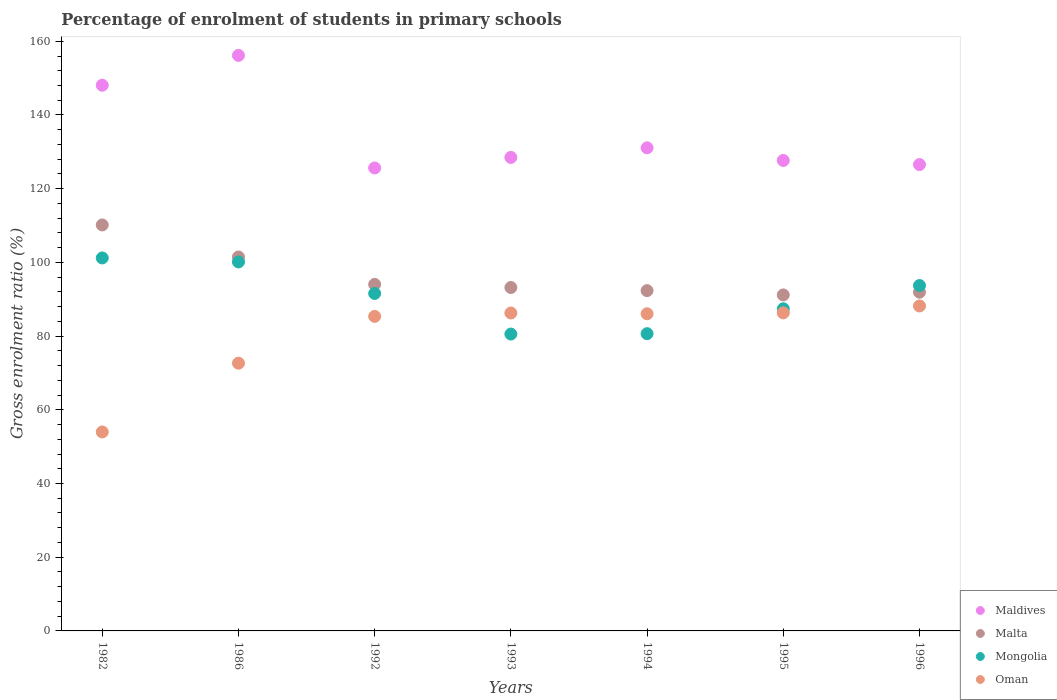How many different coloured dotlines are there?
Provide a short and direct response. 4. Is the number of dotlines equal to the number of legend labels?
Give a very brief answer. Yes. What is the percentage of students enrolled in primary schools in Maldives in 1993?
Offer a very short reply. 128.49. Across all years, what is the maximum percentage of students enrolled in primary schools in Malta?
Your answer should be very brief. 110.16. Across all years, what is the minimum percentage of students enrolled in primary schools in Mongolia?
Make the answer very short. 80.56. In which year was the percentage of students enrolled in primary schools in Maldives minimum?
Offer a very short reply. 1992. What is the total percentage of students enrolled in primary schools in Malta in the graph?
Make the answer very short. 674.29. What is the difference between the percentage of students enrolled in primary schools in Mongolia in 1982 and that in 1996?
Your response must be concise. 7.49. What is the difference between the percentage of students enrolled in primary schools in Oman in 1994 and the percentage of students enrolled in primary schools in Mongolia in 1995?
Provide a short and direct response. -1.35. What is the average percentage of students enrolled in primary schools in Mongolia per year?
Keep it short and to the point. 90.75. In the year 1982, what is the difference between the percentage of students enrolled in primary schools in Maldives and percentage of students enrolled in primary schools in Oman?
Offer a terse response. 94.08. What is the ratio of the percentage of students enrolled in primary schools in Mongolia in 1982 to that in 1994?
Provide a short and direct response. 1.25. Is the percentage of students enrolled in primary schools in Maldives in 1986 less than that in 1992?
Your answer should be compact. No. What is the difference between the highest and the second highest percentage of students enrolled in primary schools in Mongolia?
Give a very brief answer. 1.08. What is the difference between the highest and the lowest percentage of students enrolled in primary schools in Mongolia?
Offer a terse response. 20.65. In how many years, is the percentage of students enrolled in primary schools in Mongolia greater than the average percentage of students enrolled in primary schools in Mongolia taken over all years?
Your answer should be compact. 4. Is it the case that in every year, the sum of the percentage of students enrolled in primary schools in Mongolia and percentage of students enrolled in primary schools in Maldives  is greater than the sum of percentage of students enrolled in primary schools in Malta and percentage of students enrolled in primary schools in Oman?
Offer a very short reply. Yes. Is it the case that in every year, the sum of the percentage of students enrolled in primary schools in Malta and percentage of students enrolled in primary schools in Mongolia  is greater than the percentage of students enrolled in primary schools in Maldives?
Your response must be concise. Yes. Does the percentage of students enrolled in primary schools in Oman monotonically increase over the years?
Offer a very short reply. No. Is the percentage of students enrolled in primary schools in Maldives strictly greater than the percentage of students enrolled in primary schools in Oman over the years?
Keep it short and to the point. Yes. Is the percentage of students enrolled in primary schools in Oman strictly less than the percentage of students enrolled in primary schools in Malta over the years?
Make the answer very short. Yes. How many dotlines are there?
Your response must be concise. 4. How many years are there in the graph?
Your response must be concise. 7. What is the difference between two consecutive major ticks on the Y-axis?
Ensure brevity in your answer.  20. Does the graph contain any zero values?
Offer a terse response. No. Does the graph contain grids?
Provide a short and direct response. No. How many legend labels are there?
Give a very brief answer. 4. What is the title of the graph?
Your answer should be very brief. Percentage of enrolment of students in primary schools. Does "Ecuador" appear as one of the legend labels in the graph?
Keep it short and to the point. No. What is the Gross enrolment ratio (%) in Maldives in 1982?
Keep it short and to the point. 148.08. What is the Gross enrolment ratio (%) of Malta in 1982?
Provide a short and direct response. 110.16. What is the Gross enrolment ratio (%) of Mongolia in 1982?
Your response must be concise. 101.21. What is the Gross enrolment ratio (%) in Oman in 1982?
Ensure brevity in your answer.  53.99. What is the Gross enrolment ratio (%) in Maldives in 1986?
Keep it short and to the point. 156.17. What is the Gross enrolment ratio (%) of Malta in 1986?
Your response must be concise. 101.47. What is the Gross enrolment ratio (%) of Mongolia in 1986?
Give a very brief answer. 100.12. What is the Gross enrolment ratio (%) of Oman in 1986?
Your response must be concise. 72.65. What is the Gross enrolment ratio (%) in Maldives in 1992?
Keep it short and to the point. 125.62. What is the Gross enrolment ratio (%) in Malta in 1992?
Keep it short and to the point. 94.04. What is the Gross enrolment ratio (%) of Mongolia in 1992?
Ensure brevity in your answer.  91.57. What is the Gross enrolment ratio (%) of Oman in 1992?
Your answer should be compact. 85.35. What is the Gross enrolment ratio (%) of Maldives in 1993?
Offer a terse response. 128.49. What is the Gross enrolment ratio (%) in Malta in 1993?
Offer a very short reply. 93.19. What is the Gross enrolment ratio (%) in Mongolia in 1993?
Provide a succinct answer. 80.56. What is the Gross enrolment ratio (%) of Oman in 1993?
Keep it short and to the point. 86.27. What is the Gross enrolment ratio (%) of Maldives in 1994?
Provide a succinct answer. 131.1. What is the Gross enrolment ratio (%) of Malta in 1994?
Provide a succinct answer. 92.34. What is the Gross enrolment ratio (%) in Mongolia in 1994?
Your response must be concise. 80.66. What is the Gross enrolment ratio (%) of Oman in 1994?
Your answer should be compact. 86.07. What is the Gross enrolment ratio (%) of Maldives in 1995?
Provide a succinct answer. 127.66. What is the Gross enrolment ratio (%) in Malta in 1995?
Provide a short and direct response. 91.18. What is the Gross enrolment ratio (%) in Mongolia in 1995?
Your answer should be very brief. 87.42. What is the Gross enrolment ratio (%) in Oman in 1995?
Your answer should be compact. 86.31. What is the Gross enrolment ratio (%) in Maldives in 1996?
Your response must be concise. 126.55. What is the Gross enrolment ratio (%) of Malta in 1996?
Keep it short and to the point. 91.91. What is the Gross enrolment ratio (%) in Mongolia in 1996?
Your answer should be compact. 93.72. What is the Gross enrolment ratio (%) in Oman in 1996?
Keep it short and to the point. 88.18. Across all years, what is the maximum Gross enrolment ratio (%) of Maldives?
Make the answer very short. 156.17. Across all years, what is the maximum Gross enrolment ratio (%) of Malta?
Provide a succinct answer. 110.16. Across all years, what is the maximum Gross enrolment ratio (%) of Mongolia?
Give a very brief answer. 101.21. Across all years, what is the maximum Gross enrolment ratio (%) in Oman?
Your answer should be compact. 88.18. Across all years, what is the minimum Gross enrolment ratio (%) in Maldives?
Offer a terse response. 125.62. Across all years, what is the minimum Gross enrolment ratio (%) in Malta?
Ensure brevity in your answer.  91.18. Across all years, what is the minimum Gross enrolment ratio (%) in Mongolia?
Your response must be concise. 80.56. Across all years, what is the minimum Gross enrolment ratio (%) of Oman?
Your answer should be very brief. 53.99. What is the total Gross enrolment ratio (%) of Maldives in the graph?
Ensure brevity in your answer.  943.66. What is the total Gross enrolment ratio (%) in Malta in the graph?
Give a very brief answer. 674.29. What is the total Gross enrolment ratio (%) in Mongolia in the graph?
Make the answer very short. 635.26. What is the total Gross enrolment ratio (%) of Oman in the graph?
Your answer should be very brief. 558.82. What is the difference between the Gross enrolment ratio (%) in Maldives in 1982 and that in 1986?
Your response must be concise. -8.09. What is the difference between the Gross enrolment ratio (%) of Malta in 1982 and that in 1986?
Give a very brief answer. 8.7. What is the difference between the Gross enrolment ratio (%) of Mongolia in 1982 and that in 1986?
Provide a succinct answer. 1.08. What is the difference between the Gross enrolment ratio (%) of Oman in 1982 and that in 1986?
Offer a terse response. -18.66. What is the difference between the Gross enrolment ratio (%) in Maldives in 1982 and that in 1992?
Make the answer very short. 22.45. What is the difference between the Gross enrolment ratio (%) of Malta in 1982 and that in 1992?
Make the answer very short. 16.13. What is the difference between the Gross enrolment ratio (%) in Mongolia in 1982 and that in 1992?
Ensure brevity in your answer.  9.64. What is the difference between the Gross enrolment ratio (%) of Oman in 1982 and that in 1992?
Provide a short and direct response. -31.36. What is the difference between the Gross enrolment ratio (%) in Maldives in 1982 and that in 1993?
Provide a short and direct response. 19.59. What is the difference between the Gross enrolment ratio (%) in Malta in 1982 and that in 1993?
Make the answer very short. 16.98. What is the difference between the Gross enrolment ratio (%) in Mongolia in 1982 and that in 1993?
Make the answer very short. 20.65. What is the difference between the Gross enrolment ratio (%) of Oman in 1982 and that in 1993?
Ensure brevity in your answer.  -32.28. What is the difference between the Gross enrolment ratio (%) in Maldives in 1982 and that in 1994?
Provide a succinct answer. 16.98. What is the difference between the Gross enrolment ratio (%) in Malta in 1982 and that in 1994?
Ensure brevity in your answer.  17.82. What is the difference between the Gross enrolment ratio (%) of Mongolia in 1982 and that in 1994?
Your answer should be very brief. 20.55. What is the difference between the Gross enrolment ratio (%) in Oman in 1982 and that in 1994?
Your answer should be very brief. -32.08. What is the difference between the Gross enrolment ratio (%) of Maldives in 1982 and that in 1995?
Provide a succinct answer. 20.41. What is the difference between the Gross enrolment ratio (%) of Malta in 1982 and that in 1995?
Your answer should be very brief. 18.99. What is the difference between the Gross enrolment ratio (%) in Mongolia in 1982 and that in 1995?
Your answer should be compact. 13.79. What is the difference between the Gross enrolment ratio (%) in Oman in 1982 and that in 1995?
Make the answer very short. -32.32. What is the difference between the Gross enrolment ratio (%) of Maldives in 1982 and that in 1996?
Provide a short and direct response. 21.53. What is the difference between the Gross enrolment ratio (%) of Malta in 1982 and that in 1996?
Ensure brevity in your answer.  18.25. What is the difference between the Gross enrolment ratio (%) of Mongolia in 1982 and that in 1996?
Your response must be concise. 7.49. What is the difference between the Gross enrolment ratio (%) of Oman in 1982 and that in 1996?
Your answer should be compact. -34.19. What is the difference between the Gross enrolment ratio (%) in Maldives in 1986 and that in 1992?
Your answer should be compact. 30.55. What is the difference between the Gross enrolment ratio (%) in Malta in 1986 and that in 1992?
Your answer should be very brief. 7.43. What is the difference between the Gross enrolment ratio (%) in Mongolia in 1986 and that in 1992?
Your answer should be very brief. 8.55. What is the difference between the Gross enrolment ratio (%) of Oman in 1986 and that in 1992?
Keep it short and to the point. -12.7. What is the difference between the Gross enrolment ratio (%) in Maldives in 1986 and that in 1993?
Your answer should be very brief. 27.68. What is the difference between the Gross enrolment ratio (%) in Malta in 1986 and that in 1993?
Keep it short and to the point. 8.28. What is the difference between the Gross enrolment ratio (%) in Mongolia in 1986 and that in 1993?
Provide a succinct answer. 19.57. What is the difference between the Gross enrolment ratio (%) in Oman in 1986 and that in 1993?
Your answer should be compact. -13.62. What is the difference between the Gross enrolment ratio (%) in Maldives in 1986 and that in 1994?
Give a very brief answer. 25.07. What is the difference between the Gross enrolment ratio (%) in Malta in 1986 and that in 1994?
Provide a short and direct response. 9.13. What is the difference between the Gross enrolment ratio (%) of Mongolia in 1986 and that in 1994?
Keep it short and to the point. 19.46. What is the difference between the Gross enrolment ratio (%) of Oman in 1986 and that in 1994?
Ensure brevity in your answer.  -13.42. What is the difference between the Gross enrolment ratio (%) in Maldives in 1986 and that in 1995?
Your response must be concise. 28.51. What is the difference between the Gross enrolment ratio (%) in Malta in 1986 and that in 1995?
Offer a very short reply. 10.29. What is the difference between the Gross enrolment ratio (%) of Mongolia in 1986 and that in 1995?
Your response must be concise. 12.71. What is the difference between the Gross enrolment ratio (%) of Oman in 1986 and that in 1995?
Provide a succinct answer. -13.66. What is the difference between the Gross enrolment ratio (%) in Maldives in 1986 and that in 1996?
Offer a terse response. 29.62. What is the difference between the Gross enrolment ratio (%) in Malta in 1986 and that in 1996?
Offer a very short reply. 9.55. What is the difference between the Gross enrolment ratio (%) in Mongolia in 1986 and that in 1996?
Give a very brief answer. 6.4. What is the difference between the Gross enrolment ratio (%) of Oman in 1986 and that in 1996?
Provide a short and direct response. -15.53. What is the difference between the Gross enrolment ratio (%) in Maldives in 1992 and that in 1993?
Your response must be concise. -2.86. What is the difference between the Gross enrolment ratio (%) of Malta in 1992 and that in 1993?
Offer a very short reply. 0.85. What is the difference between the Gross enrolment ratio (%) of Mongolia in 1992 and that in 1993?
Offer a terse response. 11.02. What is the difference between the Gross enrolment ratio (%) of Oman in 1992 and that in 1993?
Make the answer very short. -0.92. What is the difference between the Gross enrolment ratio (%) of Maldives in 1992 and that in 1994?
Ensure brevity in your answer.  -5.47. What is the difference between the Gross enrolment ratio (%) in Malta in 1992 and that in 1994?
Offer a terse response. 1.7. What is the difference between the Gross enrolment ratio (%) of Mongolia in 1992 and that in 1994?
Offer a very short reply. 10.91. What is the difference between the Gross enrolment ratio (%) of Oman in 1992 and that in 1994?
Keep it short and to the point. -0.72. What is the difference between the Gross enrolment ratio (%) in Maldives in 1992 and that in 1995?
Your response must be concise. -2.04. What is the difference between the Gross enrolment ratio (%) in Malta in 1992 and that in 1995?
Ensure brevity in your answer.  2.86. What is the difference between the Gross enrolment ratio (%) in Mongolia in 1992 and that in 1995?
Your answer should be compact. 4.16. What is the difference between the Gross enrolment ratio (%) of Oman in 1992 and that in 1995?
Your answer should be very brief. -0.97. What is the difference between the Gross enrolment ratio (%) in Maldives in 1992 and that in 1996?
Give a very brief answer. -0.93. What is the difference between the Gross enrolment ratio (%) of Malta in 1992 and that in 1996?
Provide a short and direct response. 2.12. What is the difference between the Gross enrolment ratio (%) of Mongolia in 1992 and that in 1996?
Provide a short and direct response. -2.15. What is the difference between the Gross enrolment ratio (%) in Oman in 1992 and that in 1996?
Provide a short and direct response. -2.83. What is the difference between the Gross enrolment ratio (%) in Maldives in 1993 and that in 1994?
Your answer should be compact. -2.61. What is the difference between the Gross enrolment ratio (%) in Malta in 1993 and that in 1994?
Ensure brevity in your answer.  0.84. What is the difference between the Gross enrolment ratio (%) in Mongolia in 1993 and that in 1994?
Ensure brevity in your answer.  -0.1. What is the difference between the Gross enrolment ratio (%) in Oman in 1993 and that in 1994?
Provide a succinct answer. 0.2. What is the difference between the Gross enrolment ratio (%) of Maldives in 1993 and that in 1995?
Offer a terse response. 0.82. What is the difference between the Gross enrolment ratio (%) in Malta in 1993 and that in 1995?
Ensure brevity in your answer.  2.01. What is the difference between the Gross enrolment ratio (%) of Mongolia in 1993 and that in 1995?
Give a very brief answer. -6.86. What is the difference between the Gross enrolment ratio (%) in Oman in 1993 and that in 1995?
Your answer should be very brief. -0.04. What is the difference between the Gross enrolment ratio (%) in Maldives in 1993 and that in 1996?
Your answer should be compact. 1.94. What is the difference between the Gross enrolment ratio (%) in Malta in 1993 and that in 1996?
Ensure brevity in your answer.  1.27. What is the difference between the Gross enrolment ratio (%) in Mongolia in 1993 and that in 1996?
Offer a terse response. -13.16. What is the difference between the Gross enrolment ratio (%) in Oman in 1993 and that in 1996?
Provide a short and direct response. -1.91. What is the difference between the Gross enrolment ratio (%) in Maldives in 1994 and that in 1995?
Keep it short and to the point. 3.43. What is the difference between the Gross enrolment ratio (%) in Malta in 1994 and that in 1995?
Keep it short and to the point. 1.17. What is the difference between the Gross enrolment ratio (%) of Mongolia in 1994 and that in 1995?
Make the answer very short. -6.76. What is the difference between the Gross enrolment ratio (%) in Oman in 1994 and that in 1995?
Make the answer very short. -0.24. What is the difference between the Gross enrolment ratio (%) in Maldives in 1994 and that in 1996?
Ensure brevity in your answer.  4.55. What is the difference between the Gross enrolment ratio (%) in Malta in 1994 and that in 1996?
Ensure brevity in your answer.  0.43. What is the difference between the Gross enrolment ratio (%) in Mongolia in 1994 and that in 1996?
Make the answer very short. -13.06. What is the difference between the Gross enrolment ratio (%) of Oman in 1994 and that in 1996?
Provide a short and direct response. -2.11. What is the difference between the Gross enrolment ratio (%) of Maldives in 1995 and that in 1996?
Your response must be concise. 1.11. What is the difference between the Gross enrolment ratio (%) in Malta in 1995 and that in 1996?
Ensure brevity in your answer.  -0.74. What is the difference between the Gross enrolment ratio (%) in Mongolia in 1995 and that in 1996?
Your response must be concise. -6.31. What is the difference between the Gross enrolment ratio (%) in Oman in 1995 and that in 1996?
Give a very brief answer. -1.87. What is the difference between the Gross enrolment ratio (%) of Maldives in 1982 and the Gross enrolment ratio (%) of Malta in 1986?
Your answer should be compact. 46.61. What is the difference between the Gross enrolment ratio (%) in Maldives in 1982 and the Gross enrolment ratio (%) in Mongolia in 1986?
Make the answer very short. 47.95. What is the difference between the Gross enrolment ratio (%) in Maldives in 1982 and the Gross enrolment ratio (%) in Oman in 1986?
Your response must be concise. 75.43. What is the difference between the Gross enrolment ratio (%) of Malta in 1982 and the Gross enrolment ratio (%) of Mongolia in 1986?
Your answer should be very brief. 10.04. What is the difference between the Gross enrolment ratio (%) of Malta in 1982 and the Gross enrolment ratio (%) of Oman in 1986?
Your answer should be compact. 37.52. What is the difference between the Gross enrolment ratio (%) in Mongolia in 1982 and the Gross enrolment ratio (%) in Oman in 1986?
Keep it short and to the point. 28.56. What is the difference between the Gross enrolment ratio (%) in Maldives in 1982 and the Gross enrolment ratio (%) in Malta in 1992?
Make the answer very short. 54.04. What is the difference between the Gross enrolment ratio (%) of Maldives in 1982 and the Gross enrolment ratio (%) of Mongolia in 1992?
Offer a terse response. 56.5. What is the difference between the Gross enrolment ratio (%) of Maldives in 1982 and the Gross enrolment ratio (%) of Oman in 1992?
Keep it short and to the point. 62.73. What is the difference between the Gross enrolment ratio (%) of Malta in 1982 and the Gross enrolment ratio (%) of Mongolia in 1992?
Give a very brief answer. 18.59. What is the difference between the Gross enrolment ratio (%) of Malta in 1982 and the Gross enrolment ratio (%) of Oman in 1992?
Give a very brief answer. 24.82. What is the difference between the Gross enrolment ratio (%) of Mongolia in 1982 and the Gross enrolment ratio (%) of Oman in 1992?
Provide a succinct answer. 15.86. What is the difference between the Gross enrolment ratio (%) in Maldives in 1982 and the Gross enrolment ratio (%) in Malta in 1993?
Ensure brevity in your answer.  54.89. What is the difference between the Gross enrolment ratio (%) in Maldives in 1982 and the Gross enrolment ratio (%) in Mongolia in 1993?
Your answer should be compact. 67.52. What is the difference between the Gross enrolment ratio (%) in Maldives in 1982 and the Gross enrolment ratio (%) in Oman in 1993?
Your answer should be very brief. 61.81. What is the difference between the Gross enrolment ratio (%) of Malta in 1982 and the Gross enrolment ratio (%) of Mongolia in 1993?
Keep it short and to the point. 29.61. What is the difference between the Gross enrolment ratio (%) of Malta in 1982 and the Gross enrolment ratio (%) of Oman in 1993?
Provide a succinct answer. 23.9. What is the difference between the Gross enrolment ratio (%) of Mongolia in 1982 and the Gross enrolment ratio (%) of Oman in 1993?
Provide a succinct answer. 14.94. What is the difference between the Gross enrolment ratio (%) of Maldives in 1982 and the Gross enrolment ratio (%) of Malta in 1994?
Make the answer very short. 55.73. What is the difference between the Gross enrolment ratio (%) in Maldives in 1982 and the Gross enrolment ratio (%) in Mongolia in 1994?
Provide a succinct answer. 67.42. What is the difference between the Gross enrolment ratio (%) of Maldives in 1982 and the Gross enrolment ratio (%) of Oman in 1994?
Ensure brevity in your answer.  62.01. What is the difference between the Gross enrolment ratio (%) in Malta in 1982 and the Gross enrolment ratio (%) in Mongolia in 1994?
Offer a very short reply. 29.5. What is the difference between the Gross enrolment ratio (%) in Malta in 1982 and the Gross enrolment ratio (%) in Oman in 1994?
Make the answer very short. 24.09. What is the difference between the Gross enrolment ratio (%) in Mongolia in 1982 and the Gross enrolment ratio (%) in Oman in 1994?
Offer a very short reply. 15.14. What is the difference between the Gross enrolment ratio (%) of Maldives in 1982 and the Gross enrolment ratio (%) of Malta in 1995?
Provide a short and direct response. 56.9. What is the difference between the Gross enrolment ratio (%) in Maldives in 1982 and the Gross enrolment ratio (%) in Mongolia in 1995?
Your response must be concise. 60.66. What is the difference between the Gross enrolment ratio (%) in Maldives in 1982 and the Gross enrolment ratio (%) in Oman in 1995?
Offer a terse response. 61.76. What is the difference between the Gross enrolment ratio (%) of Malta in 1982 and the Gross enrolment ratio (%) of Mongolia in 1995?
Keep it short and to the point. 22.75. What is the difference between the Gross enrolment ratio (%) in Malta in 1982 and the Gross enrolment ratio (%) in Oman in 1995?
Your answer should be compact. 23.85. What is the difference between the Gross enrolment ratio (%) in Mongolia in 1982 and the Gross enrolment ratio (%) in Oman in 1995?
Keep it short and to the point. 14.9. What is the difference between the Gross enrolment ratio (%) of Maldives in 1982 and the Gross enrolment ratio (%) of Malta in 1996?
Your answer should be very brief. 56.16. What is the difference between the Gross enrolment ratio (%) of Maldives in 1982 and the Gross enrolment ratio (%) of Mongolia in 1996?
Make the answer very short. 54.35. What is the difference between the Gross enrolment ratio (%) in Maldives in 1982 and the Gross enrolment ratio (%) in Oman in 1996?
Your response must be concise. 59.9. What is the difference between the Gross enrolment ratio (%) in Malta in 1982 and the Gross enrolment ratio (%) in Mongolia in 1996?
Offer a very short reply. 16.44. What is the difference between the Gross enrolment ratio (%) in Malta in 1982 and the Gross enrolment ratio (%) in Oman in 1996?
Keep it short and to the point. 21.98. What is the difference between the Gross enrolment ratio (%) in Mongolia in 1982 and the Gross enrolment ratio (%) in Oman in 1996?
Your answer should be compact. 13.03. What is the difference between the Gross enrolment ratio (%) of Maldives in 1986 and the Gross enrolment ratio (%) of Malta in 1992?
Your response must be concise. 62.13. What is the difference between the Gross enrolment ratio (%) of Maldives in 1986 and the Gross enrolment ratio (%) of Mongolia in 1992?
Keep it short and to the point. 64.6. What is the difference between the Gross enrolment ratio (%) in Maldives in 1986 and the Gross enrolment ratio (%) in Oman in 1992?
Give a very brief answer. 70.82. What is the difference between the Gross enrolment ratio (%) of Malta in 1986 and the Gross enrolment ratio (%) of Mongolia in 1992?
Ensure brevity in your answer.  9.89. What is the difference between the Gross enrolment ratio (%) of Malta in 1986 and the Gross enrolment ratio (%) of Oman in 1992?
Ensure brevity in your answer.  16.12. What is the difference between the Gross enrolment ratio (%) in Mongolia in 1986 and the Gross enrolment ratio (%) in Oman in 1992?
Make the answer very short. 14.78. What is the difference between the Gross enrolment ratio (%) of Maldives in 1986 and the Gross enrolment ratio (%) of Malta in 1993?
Provide a short and direct response. 62.98. What is the difference between the Gross enrolment ratio (%) in Maldives in 1986 and the Gross enrolment ratio (%) in Mongolia in 1993?
Your answer should be compact. 75.61. What is the difference between the Gross enrolment ratio (%) of Maldives in 1986 and the Gross enrolment ratio (%) of Oman in 1993?
Make the answer very short. 69.9. What is the difference between the Gross enrolment ratio (%) of Malta in 1986 and the Gross enrolment ratio (%) of Mongolia in 1993?
Your answer should be very brief. 20.91. What is the difference between the Gross enrolment ratio (%) of Malta in 1986 and the Gross enrolment ratio (%) of Oman in 1993?
Your answer should be very brief. 15.2. What is the difference between the Gross enrolment ratio (%) of Mongolia in 1986 and the Gross enrolment ratio (%) of Oman in 1993?
Your answer should be very brief. 13.86. What is the difference between the Gross enrolment ratio (%) of Maldives in 1986 and the Gross enrolment ratio (%) of Malta in 1994?
Keep it short and to the point. 63.83. What is the difference between the Gross enrolment ratio (%) in Maldives in 1986 and the Gross enrolment ratio (%) in Mongolia in 1994?
Offer a terse response. 75.51. What is the difference between the Gross enrolment ratio (%) of Maldives in 1986 and the Gross enrolment ratio (%) of Oman in 1994?
Your answer should be compact. 70.1. What is the difference between the Gross enrolment ratio (%) of Malta in 1986 and the Gross enrolment ratio (%) of Mongolia in 1994?
Offer a very short reply. 20.81. What is the difference between the Gross enrolment ratio (%) in Malta in 1986 and the Gross enrolment ratio (%) in Oman in 1994?
Your response must be concise. 15.4. What is the difference between the Gross enrolment ratio (%) in Mongolia in 1986 and the Gross enrolment ratio (%) in Oman in 1994?
Make the answer very short. 14.05. What is the difference between the Gross enrolment ratio (%) of Maldives in 1986 and the Gross enrolment ratio (%) of Malta in 1995?
Your answer should be compact. 64.99. What is the difference between the Gross enrolment ratio (%) of Maldives in 1986 and the Gross enrolment ratio (%) of Mongolia in 1995?
Make the answer very short. 68.75. What is the difference between the Gross enrolment ratio (%) of Maldives in 1986 and the Gross enrolment ratio (%) of Oman in 1995?
Keep it short and to the point. 69.86. What is the difference between the Gross enrolment ratio (%) of Malta in 1986 and the Gross enrolment ratio (%) of Mongolia in 1995?
Your response must be concise. 14.05. What is the difference between the Gross enrolment ratio (%) of Malta in 1986 and the Gross enrolment ratio (%) of Oman in 1995?
Give a very brief answer. 15.15. What is the difference between the Gross enrolment ratio (%) in Mongolia in 1986 and the Gross enrolment ratio (%) in Oman in 1995?
Your answer should be very brief. 13.81. What is the difference between the Gross enrolment ratio (%) in Maldives in 1986 and the Gross enrolment ratio (%) in Malta in 1996?
Provide a short and direct response. 64.26. What is the difference between the Gross enrolment ratio (%) in Maldives in 1986 and the Gross enrolment ratio (%) in Mongolia in 1996?
Offer a very short reply. 62.45. What is the difference between the Gross enrolment ratio (%) in Maldives in 1986 and the Gross enrolment ratio (%) in Oman in 1996?
Offer a terse response. 67.99. What is the difference between the Gross enrolment ratio (%) of Malta in 1986 and the Gross enrolment ratio (%) of Mongolia in 1996?
Your answer should be compact. 7.75. What is the difference between the Gross enrolment ratio (%) of Malta in 1986 and the Gross enrolment ratio (%) of Oman in 1996?
Provide a short and direct response. 13.29. What is the difference between the Gross enrolment ratio (%) of Mongolia in 1986 and the Gross enrolment ratio (%) of Oman in 1996?
Your response must be concise. 11.94. What is the difference between the Gross enrolment ratio (%) of Maldives in 1992 and the Gross enrolment ratio (%) of Malta in 1993?
Offer a very short reply. 32.44. What is the difference between the Gross enrolment ratio (%) of Maldives in 1992 and the Gross enrolment ratio (%) of Mongolia in 1993?
Offer a terse response. 45.07. What is the difference between the Gross enrolment ratio (%) of Maldives in 1992 and the Gross enrolment ratio (%) of Oman in 1993?
Offer a very short reply. 39.35. What is the difference between the Gross enrolment ratio (%) in Malta in 1992 and the Gross enrolment ratio (%) in Mongolia in 1993?
Make the answer very short. 13.48. What is the difference between the Gross enrolment ratio (%) of Malta in 1992 and the Gross enrolment ratio (%) of Oman in 1993?
Your answer should be compact. 7.77. What is the difference between the Gross enrolment ratio (%) in Mongolia in 1992 and the Gross enrolment ratio (%) in Oman in 1993?
Ensure brevity in your answer.  5.3. What is the difference between the Gross enrolment ratio (%) of Maldives in 1992 and the Gross enrolment ratio (%) of Malta in 1994?
Offer a very short reply. 33.28. What is the difference between the Gross enrolment ratio (%) of Maldives in 1992 and the Gross enrolment ratio (%) of Mongolia in 1994?
Your response must be concise. 44.96. What is the difference between the Gross enrolment ratio (%) of Maldives in 1992 and the Gross enrolment ratio (%) of Oman in 1994?
Your answer should be compact. 39.55. What is the difference between the Gross enrolment ratio (%) of Malta in 1992 and the Gross enrolment ratio (%) of Mongolia in 1994?
Provide a succinct answer. 13.38. What is the difference between the Gross enrolment ratio (%) in Malta in 1992 and the Gross enrolment ratio (%) in Oman in 1994?
Provide a short and direct response. 7.97. What is the difference between the Gross enrolment ratio (%) of Mongolia in 1992 and the Gross enrolment ratio (%) of Oman in 1994?
Offer a terse response. 5.5. What is the difference between the Gross enrolment ratio (%) of Maldives in 1992 and the Gross enrolment ratio (%) of Malta in 1995?
Offer a very short reply. 34.44. What is the difference between the Gross enrolment ratio (%) of Maldives in 1992 and the Gross enrolment ratio (%) of Mongolia in 1995?
Your response must be concise. 38.21. What is the difference between the Gross enrolment ratio (%) in Maldives in 1992 and the Gross enrolment ratio (%) in Oman in 1995?
Provide a short and direct response. 39.31. What is the difference between the Gross enrolment ratio (%) in Malta in 1992 and the Gross enrolment ratio (%) in Mongolia in 1995?
Make the answer very short. 6.62. What is the difference between the Gross enrolment ratio (%) of Malta in 1992 and the Gross enrolment ratio (%) of Oman in 1995?
Make the answer very short. 7.72. What is the difference between the Gross enrolment ratio (%) in Mongolia in 1992 and the Gross enrolment ratio (%) in Oman in 1995?
Offer a terse response. 5.26. What is the difference between the Gross enrolment ratio (%) in Maldives in 1992 and the Gross enrolment ratio (%) in Malta in 1996?
Your answer should be very brief. 33.71. What is the difference between the Gross enrolment ratio (%) in Maldives in 1992 and the Gross enrolment ratio (%) in Mongolia in 1996?
Ensure brevity in your answer.  31.9. What is the difference between the Gross enrolment ratio (%) of Maldives in 1992 and the Gross enrolment ratio (%) of Oman in 1996?
Provide a succinct answer. 37.44. What is the difference between the Gross enrolment ratio (%) of Malta in 1992 and the Gross enrolment ratio (%) of Mongolia in 1996?
Give a very brief answer. 0.32. What is the difference between the Gross enrolment ratio (%) of Malta in 1992 and the Gross enrolment ratio (%) of Oman in 1996?
Ensure brevity in your answer.  5.86. What is the difference between the Gross enrolment ratio (%) in Mongolia in 1992 and the Gross enrolment ratio (%) in Oman in 1996?
Make the answer very short. 3.39. What is the difference between the Gross enrolment ratio (%) in Maldives in 1993 and the Gross enrolment ratio (%) in Malta in 1994?
Provide a succinct answer. 36.14. What is the difference between the Gross enrolment ratio (%) in Maldives in 1993 and the Gross enrolment ratio (%) in Mongolia in 1994?
Ensure brevity in your answer.  47.83. What is the difference between the Gross enrolment ratio (%) of Maldives in 1993 and the Gross enrolment ratio (%) of Oman in 1994?
Offer a terse response. 42.42. What is the difference between the Gross enrolment ratio (%) in Malta in 1993 and the Gross enrolment ratio (%) in Mongolia in 1994?
Make the answer very short. 12.53. What is the difference between the Gross enrolment ratio (%) in Malta in 1993 and the Gross enrolment ratio (%) in Oman in 1994?
Make the answer very short. 7.12. What is the difference between the Gross enrolment ratio (%) of Mongolia in 1993 and the Gross enrolment ratio (%) of Oman in 1994?
Make the answer very short. -5.51. What is the difference between the Gross enrolment ratio (%) of Maldives in 1993 and the Gross enrolment ratio (%) of Malta in 1995?
Ensure brevity in your answer.  37.31. What is the difference between the Gross enrolment ratio (%) of Maldives in 1993 and the Gross enrolment ratio (%) of Mongolia in 1995?
Your response must be concise. 41.07. What is the difference between the Gross enrolment ratio (%) in Maldives in 1993 and the Gross enrolment ratio (%) in Oman in 1995?
Your response must be concise. 42.17. What is the difference between the Gross enrolment ratio (%) of Malta in 1993 and the Gross enrolment ratio (%) of Mongolia in 1995?
Provide a short and direct response. 5.77. What is the difference between the Gross enrolment ratio (%) in Malta in 1993 and the Gross enrolment ratio (%) in Oman in 1995?
Give a very brief answer. 6.87. What is the difference between the Gross enrolment ratio (%) in Mongolia in 1993 and the Gross enrolment ratio (%) in Oman in 1995?
Your response must be concise. -5.76. What is the difference between the Gross enrolment ratio (%) of Maldives in 1993 and the Gross enrolment ratio (%) of Malta in 1996?
Your answer should be compact. 36.57. What is the difference between the Gross enrolment ratio (%) of Maldives in 1993 and the Gross enrolment ratio (%) of Mongolia in 1996?
Ensure brevity in your answer.  34.77. What is the difference between the Gross enrolment ratio (%) of Maldives in 1993 and the Gross enrolment ratio (%) of Oman in 1996?
Provide a short and direct response. 40.31. What is the difference between the Gross enrolment ratio (%) in Malta in 1993 and the Gross enrolment ratio (%) in Mongolia in 1996?
Offer a very short reply. -0.54. What is the difference between the Gross enrolment ratio (%) in Malta in 1993 and the Gross enrolment ratio (%) in Oman in 1996?
Give a very brief answer. 5.01. What is the difference between the Gross enrolment ratio (%) in Mongolia in 1993 and the Gross enrolment ratio (%) in Oman in 1996?
Provide a succinct answer. -7.62. What is the difference between the Gross enrolment ratio (%) in Maldives in 1994 and the Gross enrolment ratio (%) in Malta in 1995?
Ensure brevity in your answer.  39.92. What is the difference between the Gross enrolment ratio (%) of Maldives in 1994 and the Gross enrolment ratio (%) of Mongolia in 1995?
Ensure brevity in your answer.  43.68. What is the difference between the Gross enrolment ratio (%) of Maldives in 1994 and the Gross enrolment ratio (%) of Oman in 1995?
Keep it short and to the point. 44.78. What is the difference between the Gross enrolment ratio (%) in Malta in 1994 and the Gross enrolment ratio (%) in Mongolia in 1995?
Offer a terse response. 4.93. What is the difference between the Gross enrolment ratio (%) in Malta in 1994 and the Gross enrolment ratio (%) in Oman in 1995?
Provide a short and direct response. 6.03. What is the difference between the Gross enrolment ratio (%) of Mongolia in 1994 and the Gross enrolment ratio (%) of Oman in 1995?
Keep it short and to the point. -5.65. What is the difference between the Gross enrolment ratio (%) in Maldives in 1994 and the Gross enrolment ratio (%) in Malta in 1996?
Offer a terse response. 39.18. What is the difference between the Gross enrolment ratio (%) of Maldives in 1994 and the Gross enrolment ratio (%) of Mongolia in 1996?
Make the answer very short. 37.37. What is the difference between the Gross enrolment ratio (%) of Maldives in 1994 and the Gross enrolment ratio (%) of Oman in 1996?
Your answer should be very brief. 42.92. What is the difference between the Gross enrolment ratio (%) in Malta in 1994 and the Gross enrolment ratio (%) in Mongolia in 1996?
Make the answer very short. -1.38. What is the difference between the Gross enrolment ratio (%) in Malta in 1994 and the Gross enrolment ratio (%) in Oman in 1996?
Offer a terse response. 4.16. What is the difference between the Gross enrolment ratio (%) in Mongolia in 1994 and the Gross enrolment ratio (%) in Oman in 1996?
Your answer should be very brief. -7.52. What is the difference between the Gross enrolment ratio (%) in Maldives in 1995 and the Gross enrolment ratio (%) in Malta in 1996?
Give a very brief answer. 35.75. What is the difference between the Gross enrolment ratio (%) of Maldives in 1995 and the Gross enrolment ratio (%) of Mongolia in 1996?
Offer a terse response. 33.94. What is the difference between the Gross enrolment ratio (%) in Maldives in 1995 and the Gross enrolment ratio (%) in Oman in 1996?
Provide a short and direct response. 39.48. What is the difference between the Gross enrolment ratio (%) of Malta in 1995 and the Gross enrolment ratio (%) of Mongolia in 1996?
Offer a very short reply. -2.54. What is the difference between the Gross enrolment ratio (%) of Malta in 1995 and the Gross enrolment ratio (%) of Oman in 1996?
Ensure brevity in your answer.  3. What is the difference between the Gross enrolment ratio (%) of Mongolia in 1995 and the Gross enrolment ratio (%) of Oman in 1996?
Provide a short and direct response. -0.76. What is the average Gross enrolment ratio (%) in Maldives per year?
Your response must be concise. 134.81. What is the average Gross enrolment ratio (%) of Malta per year?
Your answer should be very brief. 96.33. What is the average Gross enrolment ratio (%) of Mongolia per year?
Your response must be concise. 90.75. What is the average Gross enrolment ratio (%) of Oman per year?
Provide a succinct answer. 79.83. In the year 1982, what is the difference between the Gross enrolment ratio (%) of Maldives and Gross enrolment ratio (%) of Malta?
Your answer should be compact. 37.91. In the year 1982, what is the difference between the Gross enrolment ratio (%) of Maldives and Gross enrolment ratio (%) of Mongolia?
Keep it short and to the point. 46.87. In the year 1982, what is the difference between the Gross enrolment ratio (%) in Maldives and Gross enrolment ratio (%) in Oman?
Your answer should be very brief. 94.08. In the year 1982, what is the difference between the Gross enrolment ratio (%) in Malta and Gross enrolment ratio (%) in Mongolia?
Your answer should be compact. 8.96. In the year 1982, what is the difference between the Gross enrolment ratio (%) of Malta and Gross enrolment ratio (%) of Oman?
Keep it short and to the point. 56.17. In the year 1982, what is the difference between the Gross enrolment ratio (%) in Mongolia and Gross enrolment ratio (%) in Oman?
Ensure brevity in your answer.  47.22. In the year 1986, what is the difference between the Gross enrolment ratio (%) in Maldives and Gross enrolment ratio (%) in Malta?
Your answer should be very brief. 54.7. In the year 1986, what is the difference between the Gross enrolment ratio (%) of Maldives and Gross enrolment ratio (%) of Mongolia?
Make the answer very short. 56.05. In the year 1986, what is the difference between the Gross enrolment ratio (%) in Maldives and Gross enrolment ratio (%) in Oman?
Your answer should be compact. 83.52. In the year 1986, what is the difference between the Gross enrolment ratio (%) in Malta and Gross enrolment ratio (%) in Mongolia?
Give a very brief answer. 1.34. In the year 1986, what is the difference between the Gross enrolment ratio (%) of Malta and Gross enrolment ratio (%) of Oman?
Provide a short and direct response. 28.82. In the year 1986, what is the difference between the Gross enrolment ratio (%) of Mongolia and Gross enrolment ratio (%) of Oman?
Provide a short and direct response. 27.48. In the year 1992, what is the difference between the Gross enrolment ratio (%) of Maldives and Gross enrolment ratio (%) of Malta?
Your answer should be very brief. 31.58. In the year 1992, what is the difference between the Gross enrolment ratio (%) of Maldives and Gross enrolment ratio (%) of Mongolia?
Offer a terse response. 34.05. In the year 1992, what is the difference between the Gross enrolment ratio (%) in Maldives and Gross enrolment ratio (%) in Oman?
Keep it short and to the point. 40.27. In the year 1992, what is the difference between the Gross enrolment ratio (%) of Malta and Gross enrolment ratio (%) of Mongolia?
Provide a short and direct response. 2.46. In the year 1992, what is the difference between the Gross enrolment ratio (%) in Malta and Gross enrolment ratio (%) in Oman?
Provide a succinct answer. 8.69. In the year 1992, what is the difference between the Gross enrolment ratio (%) of Mongolia and Gross enrolment ratio (%) of Oman?
Ensure brevity in your answer.  6.23. In the year 1993, what is the difference between the Gross enrolment ratio (%) in Maldives and Gross enrolment ratio (%) in Malta?
Offer a terse response. 35.3. In the year 1993, what is the difference between the Gross enrolment ratio (%) of Maldives and Gross enrolment ratio (%) of Mongolia?
Your response must be concise. 47.93. In the year 1993, what is the difference between the Gross enrolment ratio (%) in Maldives and Gross enrolment ratio (%) in Oman?
Provide a short and direct response. 42.22. In the year 1993, what is the difference between the Gross enrolment ratio (%) of Malta and Gross enrolment ratio (%) of Mongolia?
Offer a very short reply. 12.63. In the year 1993, what is the difference between the Gross enrolment ratio (%) of Malta and Gross enrolment ratio (%) of Oman?
Your answer should be compact. 6.92. In the year 1993, what is the difference between the Gross enrolment ratio (%) of Mongolia and Gross enrolment ratio (%) of Oman?
Provide a short and direct response. -5.71. In the year 1994, what is the difference between the Gross enrolment ratio (%) in Maldives and Gross enrolment ratio (%) in Malta?
Offer a very short reply. 38.75. In the year 1994, what is the difference between the Gross enrolment ratio (%) in Maldives and Gross enrolment ratio (%) in Mongolia?
Ensure brevity in your answer.  50.44. In the year 1994, what is the difference between the Gross enrolment ratio (%) of Maldives and Gross enrolment ratio (%) of Oman?
Make the answer very short. 45.03. In the year 1994, what is the difference between the Gross enrolment ratio (%) in Malta and Gross enrolment ratio (%) in Mongolia?
Keep it short and to the point. 11.68. In the year 1994, what is the difference between the Gross enrolment ratio (%) of Malta and Gross enrolment ratio (%) of Oman?
Offer a very short reply. 6.27. In the year 1994, what is the difference between the Gross enrolment ratio (%) of Mongolia and Gross enrolment ratio (%) of Oman?
Make the answer very short. -5.41. In the year 1995, what is the difference between the Gross enrolment ratio (%) of Maldives and Gross enrolment ratio (%) of Malta?
Your answer should be very brief. 36.49. In the year 1995, what is the difference between the Gross enrolment ratio (%) of Maldives and Gross enrolment ratio (%) of Mongolia?
Your response must be concise. 40.25. In the year 1995, what is the difference between the Gross enrolment ratio (%) in Maldives and Gross enrolment ratio (%) in Oman?
Ensure brevity in your answer.  41.35. In the year 1995, what is the difference between the Gross enrolment ratio (%) of Malta and Gross enrolment ratio (%) of Mongolia?
Offer a very short reply. 3.76. In the year 1995, what is the difference between the Gross enrolment ratio (%) of Malta and Gross enrolment ratio (%) of Oman?
Offer a very short reply. 4.86. In the year 1995, what is the difference between the Gross enrolment ratio (%) of Mongolia and Gross enrolment ratio (%) of Oman?
Your response must be concise. 1.1. In the year 1996, what is the difference between the Gross enrolment ratio (%) in Maldives and Gross enrolment ratio (%) in Malta?
Your answer should be very brief. 34.64. In the year 1996, what is the difference between the Gross enrolment ratio (%) in Maldives and Gross enrolment ratio (%) in Mongolia?
Keep it short and to the point. 32.83. In the year 1996, what is the difference between the Gross enrolment ratio (%) in Maldives and Gross enrolment ratio (%) in Oman?
Give a very brief answer. 38.37. In the year 1996, what is the difference between the Gross enrolment ratio (%) of Malta and Gross enrolment ratio (%) of Mongolia?
Give a very brief answer. -1.81. In the year 1996, what is the difference between the Gross enrolment ratio (%) of Malta and Gross enrolment ratio (%) of Oman?
Give a very brief answer. 3.73. In the year 1996, what is the difference between the Gross enrolment ratio (%) of Mongolia and Gross enrolment ratio (%) of Oman?
Provide a short and direct response. 5.54. What is the ratio of the Gross enrolment ratio (%) in Maldives in 1982 to that in 1986?
Your response must be concise. 0.95. What is the ratio of the Gross enrolment ratio (%) of Malta in 1982 to that in 1986?
Provide a short and direct response. 1.09. What is the ratio of the Gross enrolment ratio (%) in Mongolia in 1982 to that in 1986?
Make the answer very short. 1.01. What is the ratio of the Gross enrolment ratio (%) in Oman in 1982 to that in 1986?
Offer a very short reply. 0.74. What is the ratio of the Gross enrolment ratio (%) in Maldives in 1982 to that in 1992?
Provide a succinct answer. 1.18. What is the ratio of the Gross enrolment ratio (%) of Malta in 1982 to that in 1992?
Your answer should be very brief. 1.17. What is the ratio of the Gross enrolment ratio (%) of Mongolia in 1982 to that in 1992?
Your answer should be very brief. 1.11. What is the ratio of the Gross enrolment ratio (%) in Oman in 1982 to that in 1992?
Keep it short and to the point. 0.63. What is the ratio of the Gross enrolment ratio (%) in Maldives in 1982 to that in 1993?
Provide a short and direct response. 1.15. What is the ratio of the Gross enrolment ratio (%) in Malta in 1982 to that in 1993?
Your response must be concise. 1.18. What is the ratio of the Gross enrolment ratio (%) of Mongolia in 1982 to that in 1993?
Offer a very short reply. 1.26. What is the ratio of the Gross enrolment ratio (%) in Oman in 1982 to that in 1993?
Ensure brevity in your answer.  0.63. What is the ratio of the Gross enrolment ratio (%) in Maldives in 1982 to that in 1994?
Your answer should be very brief. 1.13. What is the ratio of the Gross enrolment ratio (%) of Malta in 1982 to that in 1994?
Your answer should be compact. 1.19. What is the ratio of the Gross enrolment ratio (%) in Mongolia in 1982 to that in 1994?
Provide a succinct answer. 1.25. What is the ratio of the Gross enrolment ratio (%) of Oman in 1982 to that in 1994?
Offer a very short reply. 0.63. What is the ratio of the Gross enrolment ratio (%) of Maldives in 1982 to that in 1995?
Provide a succinct answer. 1.16. What is the ratio of the Gross enrolment ratio (%) of Malta in 1982 to that in 1995?
Provide a succinct answer. 1.21. What is the ratio of the Gross enrolment ratio (%) of Mongolia in 1982 to that in 1995?
Ensure brevity in your answer.  1.16. What is the ratio of the Gross enrolment ratio (%) of Oman in 1982 to that in 1995?
Make the answer very short. 0.63. What is the ratio of the Gross enrolment ratio (%) of Maldives in 1982 to that in 1996?
Provide a succinct answer. 1.17. What is the ratio of the Gross enrolment ratio (%) in Malta in 1982 to that in 1996?
Your answer should be very brief. 1.2. What is the ratio of the Gross enrolment ratio (%) in Mongolia in 1982 to that in 1996?
Your answer should be very brief. 1.08. What is the ratio of the Gross enrolment ratio (%) in Oman in 1982 to that in 1996?
Your answer should be compact. 0.61. What is the ratio of the Gross enrolment ratio (%) of Maldives in 1986 to that in 1992?
Provide a succinct answer. 1.24. What is the ratio of the Gross enrolment ratio (%) of Malta in 1986 to that in 1992?
Provide a succinct answer. 1.08. What is the ratio of the Gross enrolment ratio (%) of Mongolia in 1986 to that in 1992?
Make the answer very short. 1.09. What is the ratio of the Gross enrolment ratio (%) of Oman in 1986 to that in 1992?
Give a very brief answer. 0.85. What is the ratio of the Gross enrolment ratio (%) of Maldives in 1986 to that in 1993?
Provide a short and direct response. 1.22. What is the ratio of the Gross enrolment ratio (%) of Malta in 1986 to that in 1993?
Make the answer very short. 1.09. What is the ratio of the Gross enrolment ratio (%) of Mongolia in 1986 to that in 1993?
Give a very brief answer. 1.24. What is the ratio of the Gross enrolment ratio (%) in Oman in 1986 to that in 1993?
Make the answer very short. 0.84. What is the ratio of the Gross enrolment ratio (%) in Maldives in 1986 to that in 1994?
Provide a short and direct response. 1.19. What is the ratio of the Gross enrolment ratio (%) of Malta in 1986 to that in 1994?
Your answer should be compact. 1.1. What is the ratio of the Gross enrolment ratio (%) in Mongolia in 1986 to that in 1994?
Provide a succinct answer. 1.24. What is the ratio of the Gross enrolment ratio (%) in Oman in 1986 to that in 1994?
Offer a very short reply. 0.84. What is the ratio of the Gross enrolment ratio (%) in Maldives in 1986 to that in 1995?
Provide a succinct answer. 1.22. What is the ratio of the Gross enrolment ratio (%) in Malta in 1986 to that in 1995?
Ensure brevity in your answer.  1.11. What is the ratio of the Gross enrolment ratio (%) in Mongolia in 1986 to that in 1995?
Offer a very short reply. 1.15. What is the ratio of the Gross enrolment ratio (%) of Oman in 1986 to that in 1995?
Your answer should be compact. 0.84. What is the ratio of the Gross enrolment ratio (%) in Maldives in 1986 to that in 1996?
Provide a short and direct response. 1.23. What is the ratio of the Gross enrolment ratio (%) in Malta in 1986 to that in 1996?
Ensure brevity in your answer.  1.1. What is the ratio of the Gross enrolment ratio (%) of Mongolia in 1986 to that in 1996?
Your answer should be compact. 1.07. What is the ratio of the Gross enrolment ratio (%) of Oman in 1986 to that in 1996?
Keep it short and to the point. 0.82. What is the ratio of the Gross enrolment ratio (%) of Maldives in 1992 to that in 1993?
Keep it short and to the point. 0.98. What is the ratio of the Gross enrolment ratio (%) of Malta in 1992 to that in 1993?
Your answer should be very brief. 1.01. What is the ratio of the Gross enrolment ratio (%) of Mongolia in 1992 to that in 1993?
Your answer should be compact. 1.14. What is the ratio of the Gross enrolment ratio (%) of Oman in 1992 to that in 1993?
Offer a terse response. 0.99. What is the ratio of the Gross enrolment ratio (%) of Maldives in 1992 to that in 1994?
Offer a very short reply. 0.96. What is the ratio of the Gross enrolment ratio (%) of Malta in 1992 to that in 1994?
Your answer should be compact. 1.02. What is the ratio of the Gross enrolment ratio (%) of Mongolia in 1992 to that in 1994?
Provide a short and direct response. 1.14. What is the ratio of the Gross enrolment ratio (%) in Oman in 1992 to that in 1994?
Make the answer very short. 0.99. What is the ratio of the Gross enrolment ratio (%) in Malta in 1992 to that in 1995?
Ensure brevity in your answer.  1.03. What is the ratio of the Gross enrolment ratio (%) in Mongolia in 1992 to that in 1995?
Your response must be concise. 1.05. What is the ratio of the Gross enrolment ratio (%) in Maldives in 1992 to that in 1996?
Make the answer very short. 0.99. What is the ratio of the Gross enrolment ratio (%) of Malta in 1992 to that in 1996?
Offer a terse response. 1.02. What is the ratio of the Gross enrolment ratio (%) in Mongolia in 1992 to that in 1996?
Offer a very short reply. 0.98. What is the ratio of the Gross enrolment ratio (%) in Oman in 1992 to that in 1996?
Make the answer very short. 0.97. What is the ratio of the Gross enrolment ratio (%) of Maldives in 1993 to that in 1994?
Provide a short and direct response. 0.98. What is the ratio of the Gross enrolment ratio (%) in Malta in 1993 to that in 1994?
Your answer should be compact. 1.01. What is the ratio of the Gross enrolment ratio (%) in Oman in 1993 to that in 1994?
Provide a succinct answer. 1. What is the ratio of the Gross enrolment ratio (%) of Mongolia in 1993 to that in 1995?
Ensure brevity in your answer.  0.92. What is the ratio of the Gross enrolment ratio (%) of Oman in 1993 to that in 1995?
Offer a very short reply. 1. What is the ratio of the Gross enrolment ratio (%) in Maldives in 1993 to that in 1996?
Your answer should be very brief. 1.02. What is the ratio of the Gross enrolment ratio (%) of Malta in 1993 to that in 1996?
Keep it short and to the point. 1.01. What is the ratio of the Gross enrolment ratio (%) in Mongolia in 1993 to that in 1996?
Provide a succinct answer. 0.86. What is the ratio of the Gross enrolment ratio (%) of Oman in 1993 to that in 1996?
Offer a terse response. 0.98. What is the ratio of the Gross enrolment ratio (%) in Maldives in 1994 to that in 1995?
Your answer should be compact. 1.03. What is the ratio of the Gross enrolment ratio (%) of Malta in 1994 to that in 1995?
Keep it short and to the point. 1.01. What is the ratio of the Gross enrolment ratio (%) of Mongolia in 1994 to that in 1995?
Keep it short and to the point. 0.92. What is the ratio of the Gross enrolment ratio (%) of Maldives in 1994 to that in 1996?
Provide a succinct answer. 1.04. What is the ratio of the Gross enrolment ratio (%) in Mongolia in 1994 to that in 1996?
Provide a succinct answer. 0.86. What is the ratio of the Gross enrolment ratio (%) of Oman in 1994 to that in 1996?
Offer a very short reply. 0.98. What is the ratio of the Gross enrolment ratio (%) of Maldives in 1995 to that in 1996?
Make the answer very short. 1.01. What is the ratio of the Gross enrolment ratio (%) of Mongolia in 1995 to that in 1996?
Provide a succinct answer. 0.93. What is the ratio of the Gross enrolment ratio (%) in Oman in 1995 to that in 1996?
Your response must be concise. 0.98. What is the difference between the highest and the second highest Gross enrolment ratio (%) in Maldives?
Your answer should be compact. 8.09. What is the difference between the highest and the second highest Gross enrolment ratio (%) in Malta?
Your answer should be compact. 8.7. What is the difference between the highest and the second highest Gross enrolment ratio (%) of Mongolia?
Offer a terse response. 1.08. What is the difference between the highest and the second highest Gross enrolment ratio (%) in Oman?
Your response must be concise. 1.87. What is the difference between the highest and the lowest Gross enrolment ratio (%) of Maldives?
Keep it short and to the point. 30.55. What is the difference between the highest and the lowest Gross enrolment ratio (%) in Malta?
Keep it short and to the point. 18.99. What is the difference between the highest and the lowest Gross enrolment ratio (%) of Mongolia?
Ensure brevity in your answer.  20.65. What is the difference between the highest and the lowest Gross enrolment ratio (%) in Oman?
Keep it short and to the point. 34.19. 